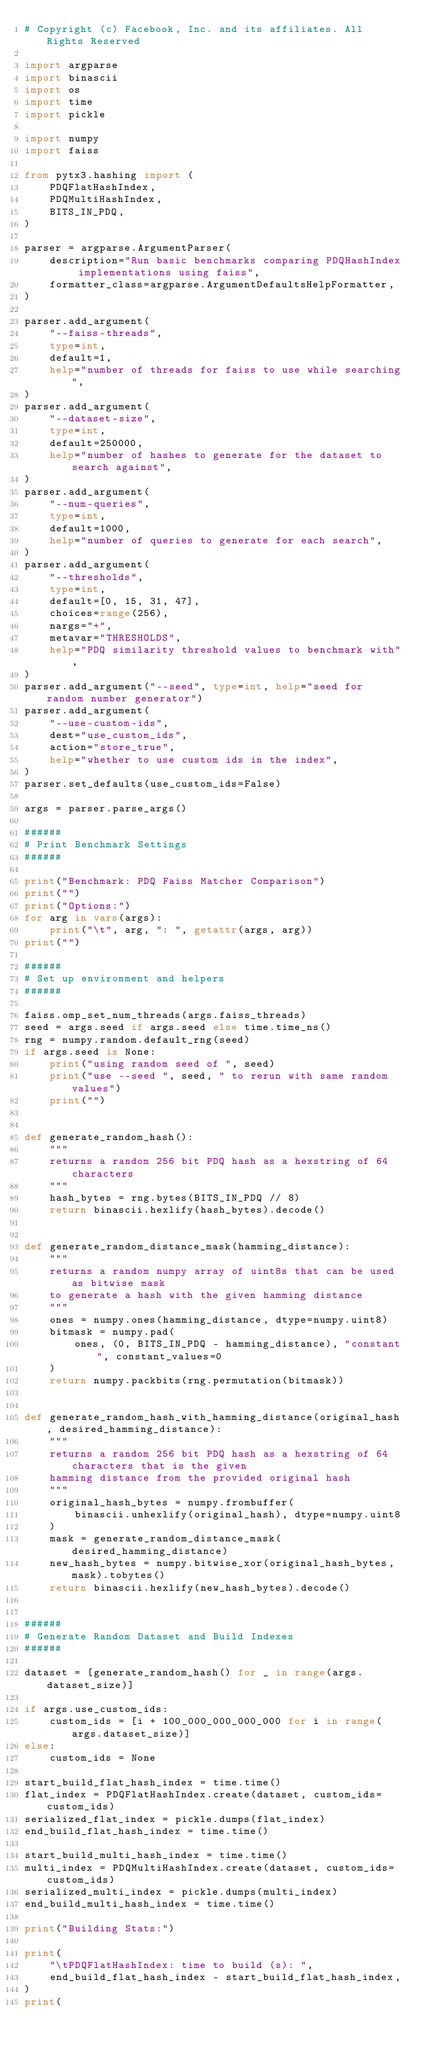Convert code to text. <code><loc_0><loc_0><loc_500><loc_500><_Python_># Copyright (c) Facebook, Inc. and its affiliates. All Rights Reserved

import argparse
import binascii
import os
import time
import pickle

import numpy
import faiss

from pytx3.hashing import (
    PDQFlatHashIndex,
    PDQMultiHashIndex,
    BITS_IN_PDQ,
)

parser = argparse.ArgumentParser(
    description="Run basic benchmarks comparing PDQHashIndex implementations using faiss",
    formatter_class=argparse.ArgumentDefaultsHelpFormatter,
)

parser.add_argument(
    "--faiss-threads",
    type=int,
    default=1,
    help="number of threads for faiss to use while searching",
)
parser.add_argument(
    "--dataset-size",
    type=int,
    default=250000,
    help="number of hashes to generate for the dataset to search against",
)
parser.add_argument(
    "--num-queries",
    type=int,
    default=1000,
    help="number of queries to generate for each search",
)
parser.add_argument(
    "--thresholds",
    type=int,
    default=[0, 15, 31, 47],
    choices=range(256),
    nargs="+",
    metavar="THRESHOLDS",
    help="PDQ similarity threshold values to benchmark with",
)
parser.add_argument("--seed", type=int, help="seed for random number generator")
parser.add_argument(
    "--use-custom-ids",
    dest="use_custom_ids",
    action="store_true",
    help="whether to use custom ids in the index",
)
parser.set_defaults(use_custom_ids=False)

args = parser.parse_args()

######
# Print Benchmark Settings
######

print("Benchmark: PDQ Faiss Matcher Comparison")
print("")
print("Options:")
for arg in vars(args):
    print("\t", arg, ": ", getattr(args, arg))
print("")

######
# Set up environment and helpers
######

faiss.omp_set_num_threads(args.faiss_threads)
seed = args.seed if args.seed else time.time_ns()
rng = numpy.random.default_rng(seed)
if args.seed is None:
    print("using random seed of ", seed)
    print("use --seed ", seed, " to rerun with same random values")
    print("")


def generate_random_hash():
    """
    returns a random 256 bit PDQ hash as a hexstring of 64 characters
    """
    hash_bytes = rng.bytes(BITS_IN_PDQ // 8)
    return binascii.hexlify(hash_bytes).decode()


def generate_random_distance_mask(hamming_distance):
    """
    returns a random numpy array of uint8s that can be used as bitwise mask
    to generate a hash with the given hamming distance
    """
    ones = numpy.ones(hamming_distance, dtype=numpy.uint8)
    bitmask = numpy.pad(
        ones, (0, BITS_IN_PDQ - hamming_distance), "constant", constant_values=0
    )
    return numpy.packbits(rng.permutation(bitmask))


def generate_random_hash_with_hamming_distance(original_hash, desired_hamming_distance):
    """
    returns a random 256 bit PDQ hash as a hexstring of 64 characters that is the given
    hamming distance from the provided original hash
    """
    original_hash_bytes = numpy.frombuffer(
        binascii.unhexlify(original_hash), dtype=numpy.uint8
    )
    mask = generate_random_distance_mask(desired_hamming_distance)
    new_hash_bytes = numpy.bitwise_xor(original_hash_bytes, mask).tobytes()
    return binascii.hexlify(new_hash_bytes).decode()


######
# Generate Random Dataset and Build Indexes
######

dataset = [generate_random_hash() for _ in range(args.dataset_size)]

if args.use_custom_ids:
    custom_ids = [i + 100_000_000_000_000 for i in range(args.dataset_size)]
else:
    custom_ids = None

start_build_flat_hash_index = time.time()
flat_index = PDQFlatHashIndex.create(dataset, custom_ids=custom_ids)
serialized_flat_index = pickle.dumps(flat_index)
end_build_flat_hash_index = time.time()

start_build_multi_hash_index = time.time()
multi_index = PDQMultiHashIndex.create(dataset, custom_ids=custom_ids)
serialized_multi_index = pickle.dumps(multi_index)
end_build_multi_hash_index = time.time()

print("Building Stats:")

print(
    "\tPDQFlatHashIndex: time to build (s): ",
    end_build_flat_hash_index - start_build_flat_hash_index,
)
print(</code> 